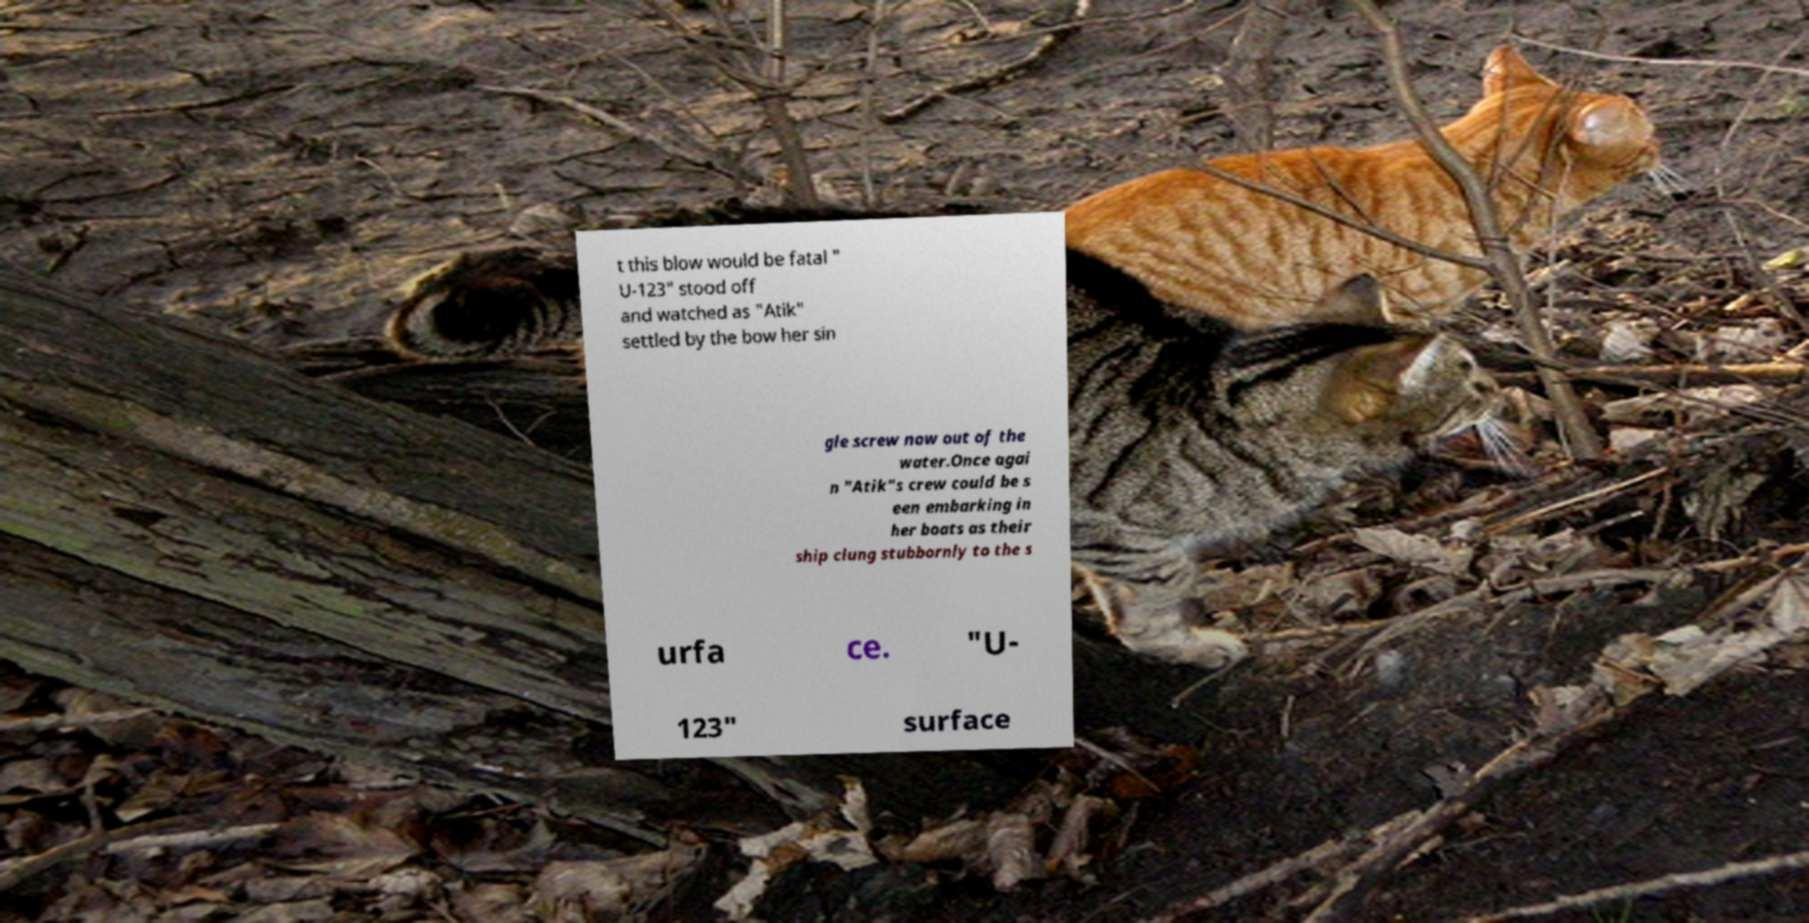Can you read and provide the text displayed in the image?This photo seems to have some interesting text. Can you extract and type it out for me? t this blow would be fatal " U-123" stood off and watched as "Atik" settled by the bow her sin gle screw now out of the water.Once agai n "Atik"s crew could be s een embarking in her boats as their ship clung stubbornly to the s urfa ce. "U- 123" surface 